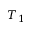<formula> <loc_0><loc_0><loc_500><loc_500>T _ { 1 }</formula> 